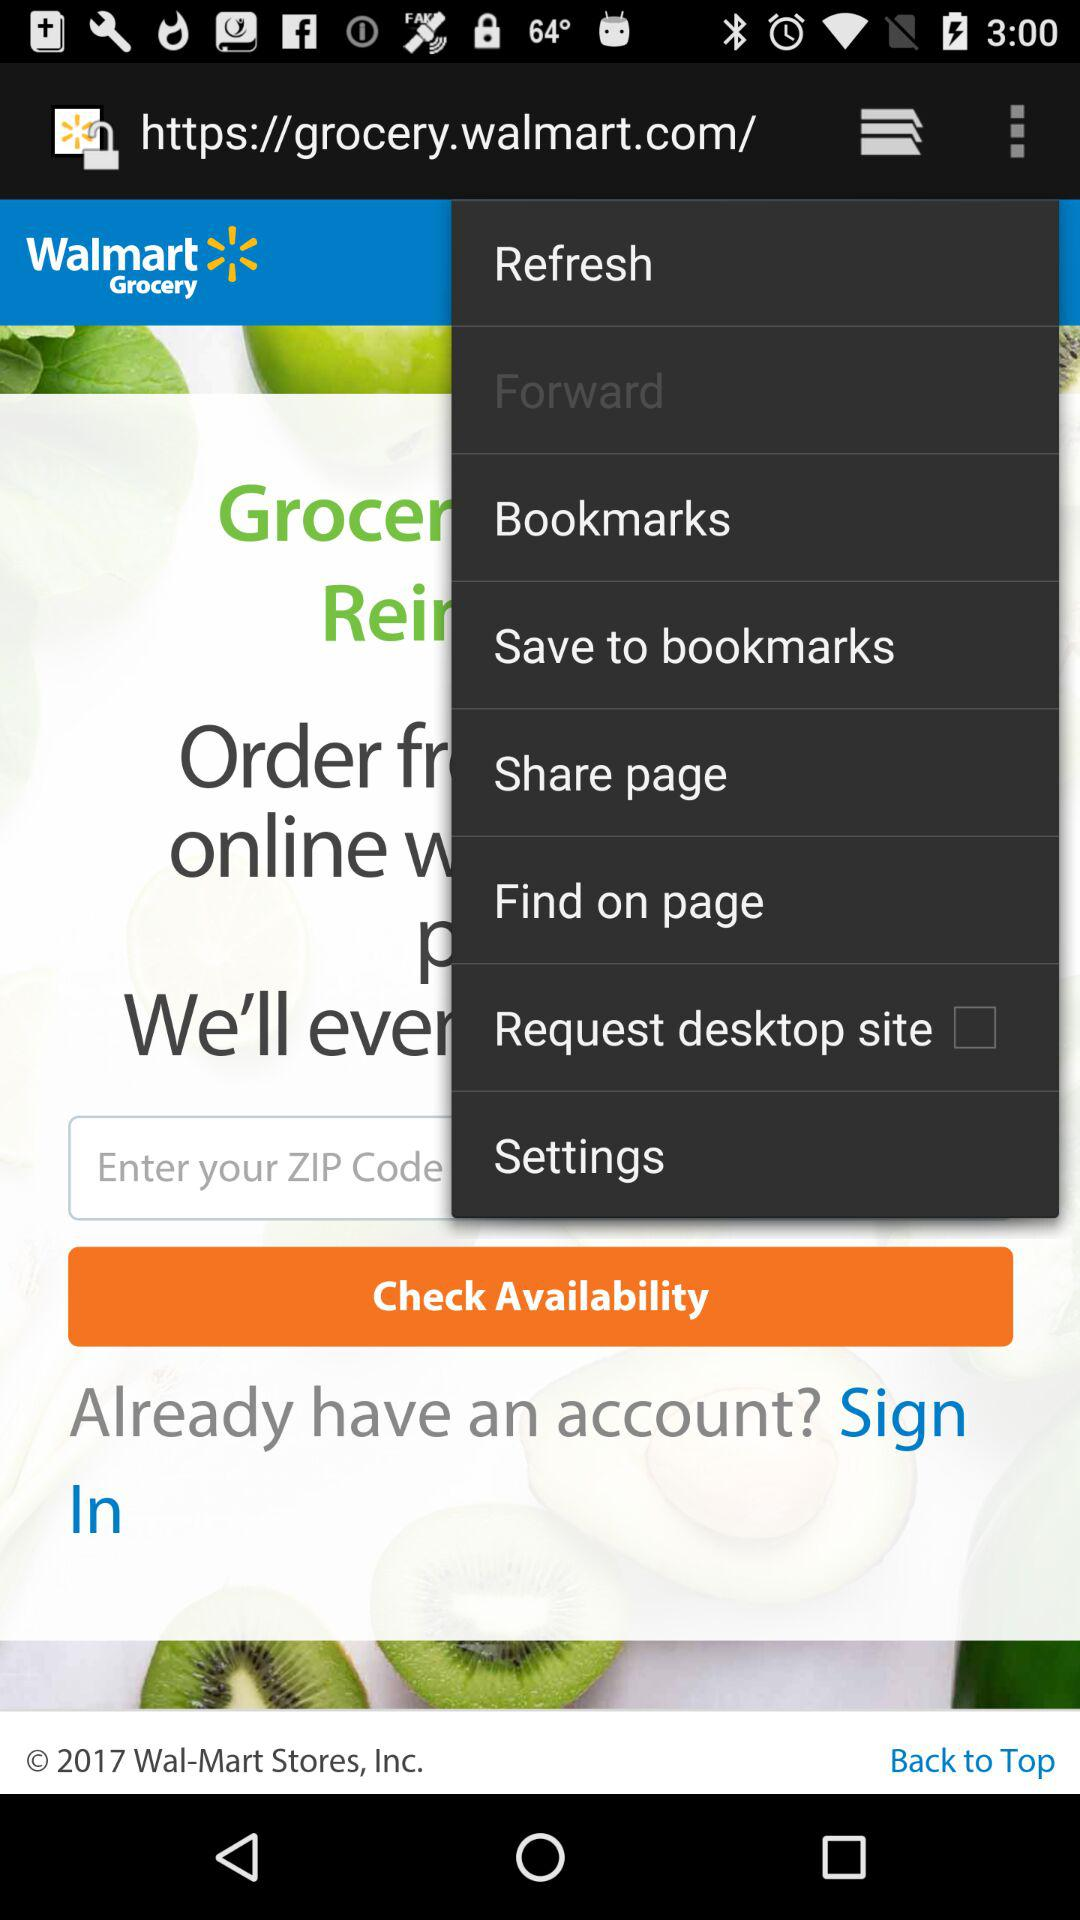What is the name of the application? The name of the application is "Walmart Grocery". 